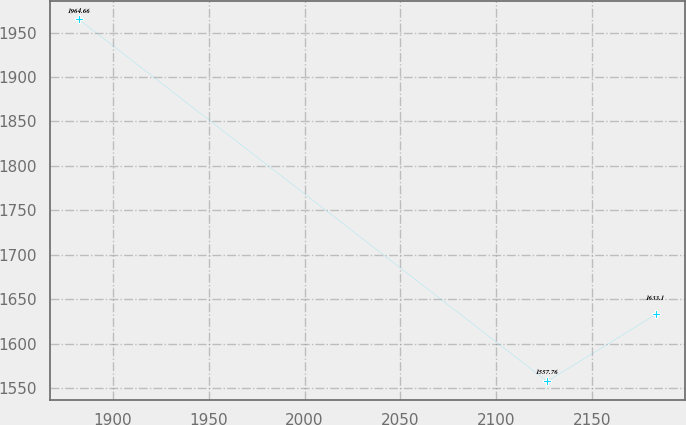Convert chart. <chart><loc_0><loc_0><loc_500><loc_500><line_chart><ecel><fcel>Unnamed: 1<nl><fcel>1882.2<fcel>1964.66<nl><fcel>2126.69<fcel>1557.76<nl><fcel>2183.44<fcel>1633.1<nl></chart> 